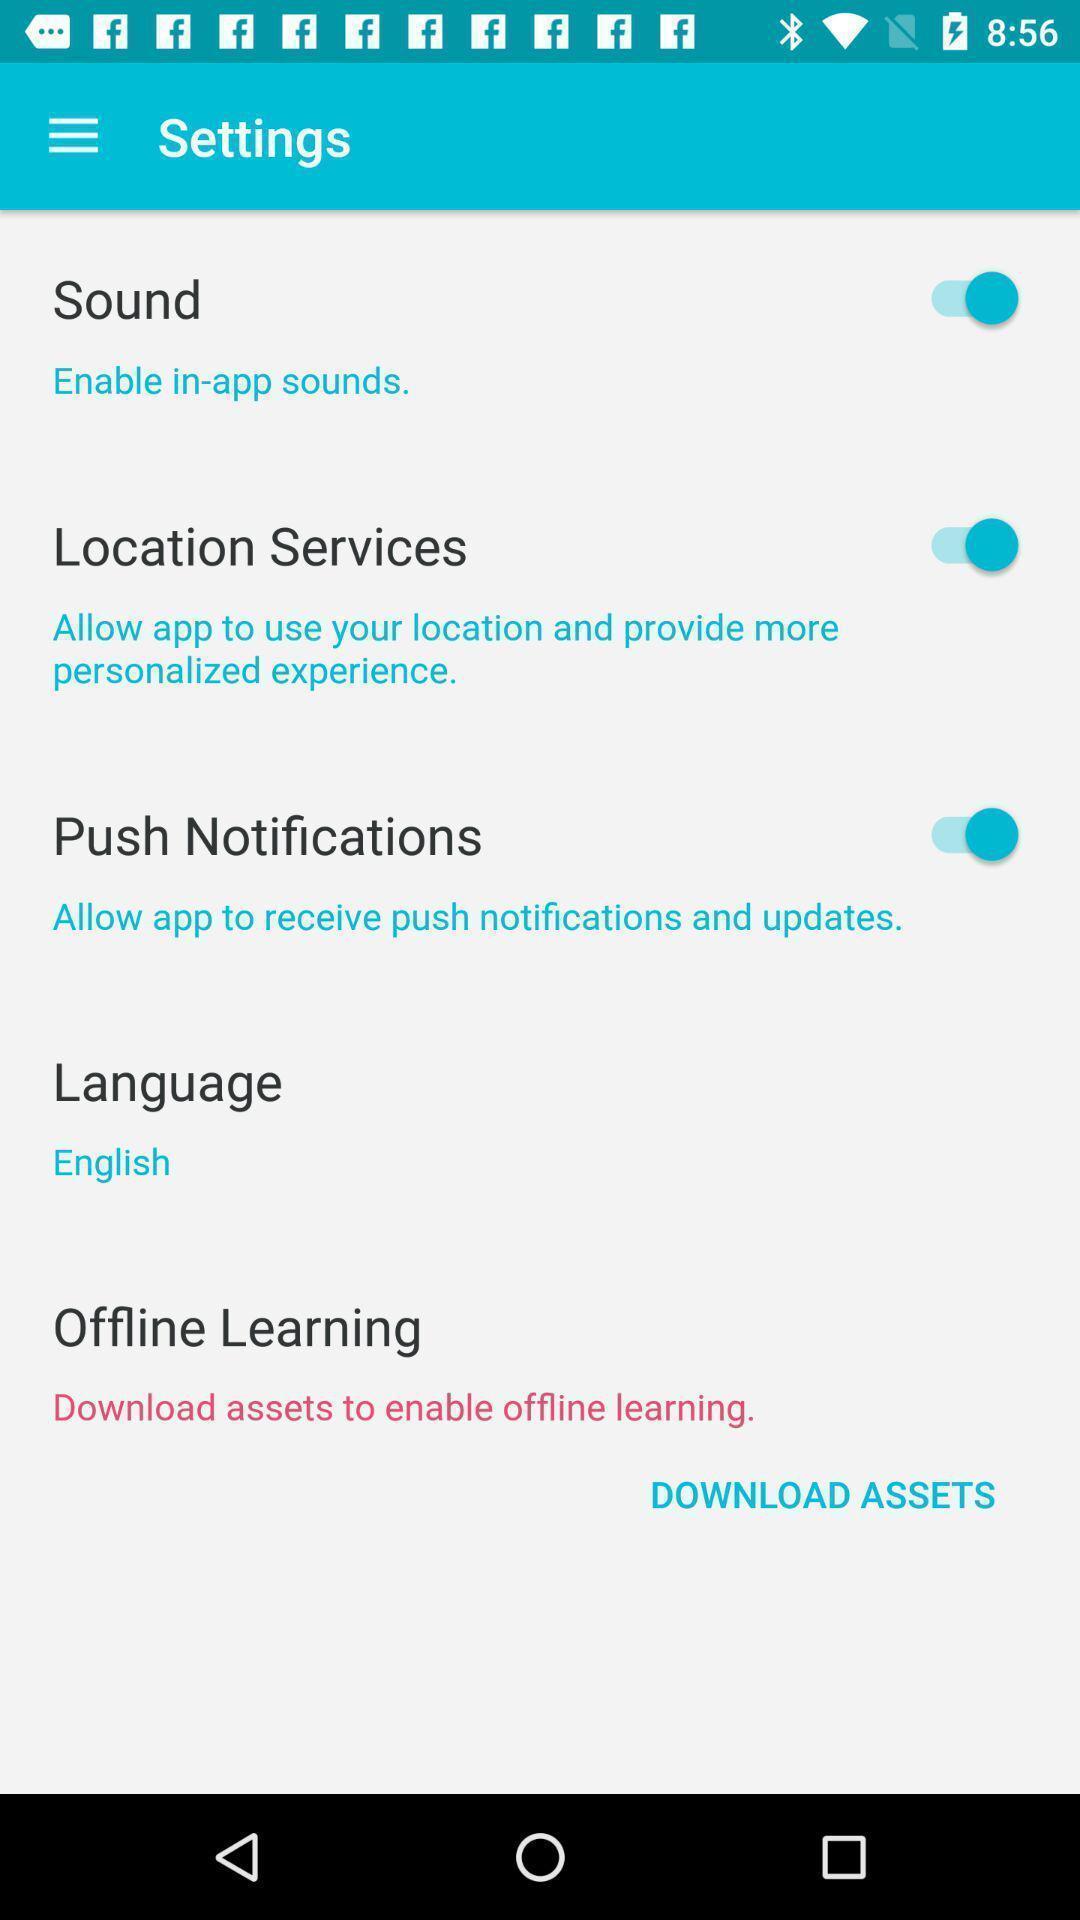Provide a detailed account of this screenshot. Screen displaying the settings page. 